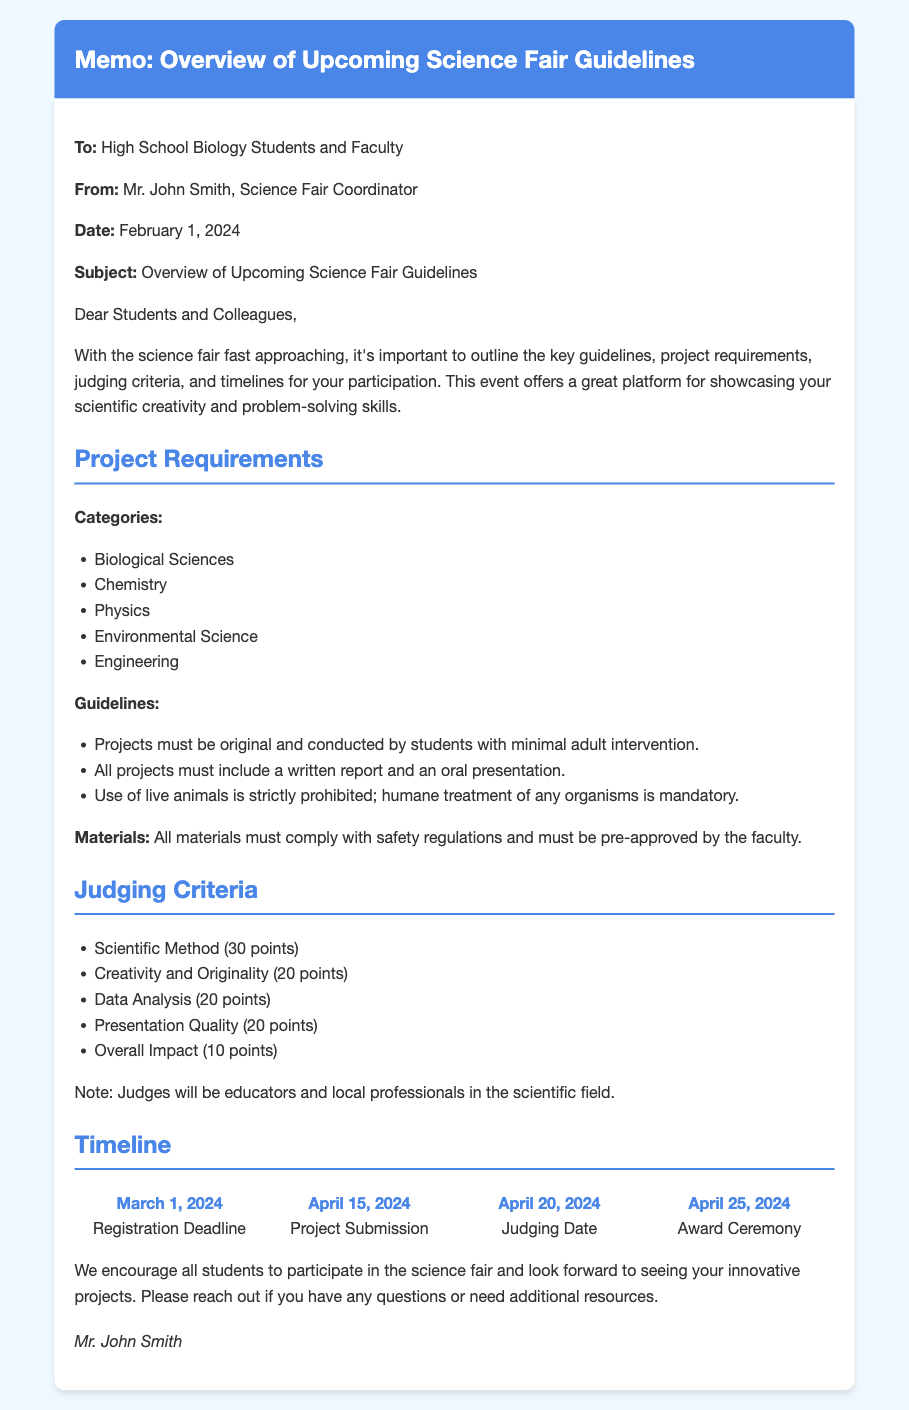what is the registration deadline? The registration deadline is listed as March 1, 2024, in the timeline section.
Answer: March 1, 2024 who is the sender of the memo? The sender's name is mentioned at the beginning of the memo as Mr. John Smith, Science Fair Coordinator.
Answer: Mr. John Smith how many points are awarded for creativity and originality? The points awarded for creativity and originality are outlined in the judging criteria section.
Answer: 20 points which projects categories are included in the guidelines? The categories are listed under project requirements, including Biological Sciences, Chemistry, Physics, Environmental Science, and Engineering.
Answer: Biological Sciences, Chemistry, Physics, Environmental Science, Engineering what materials must comply with safety regulations? The memo states that all materials used in projects must comply with safety regulations and require faculty approval.
Answer: All materials how will judges be selected for the fair? The document mentions that judges will be educators and local professionals in the scientific field.
Answer: Educators and local professionals what date is the award ceremony scheduled for? The date for the award ceremony is provided in the timeline section of the memo.
Answer: April 25, 2024 what is an essential guideline regarding the use of live animals? The guidelines state that the use of live animals in projects is strictly prohibited.
Answer: Prohibited 